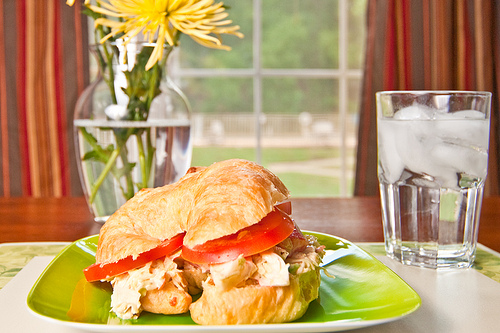What is on the sandwich? The sandwich is filled with chicken and tomato slices. 